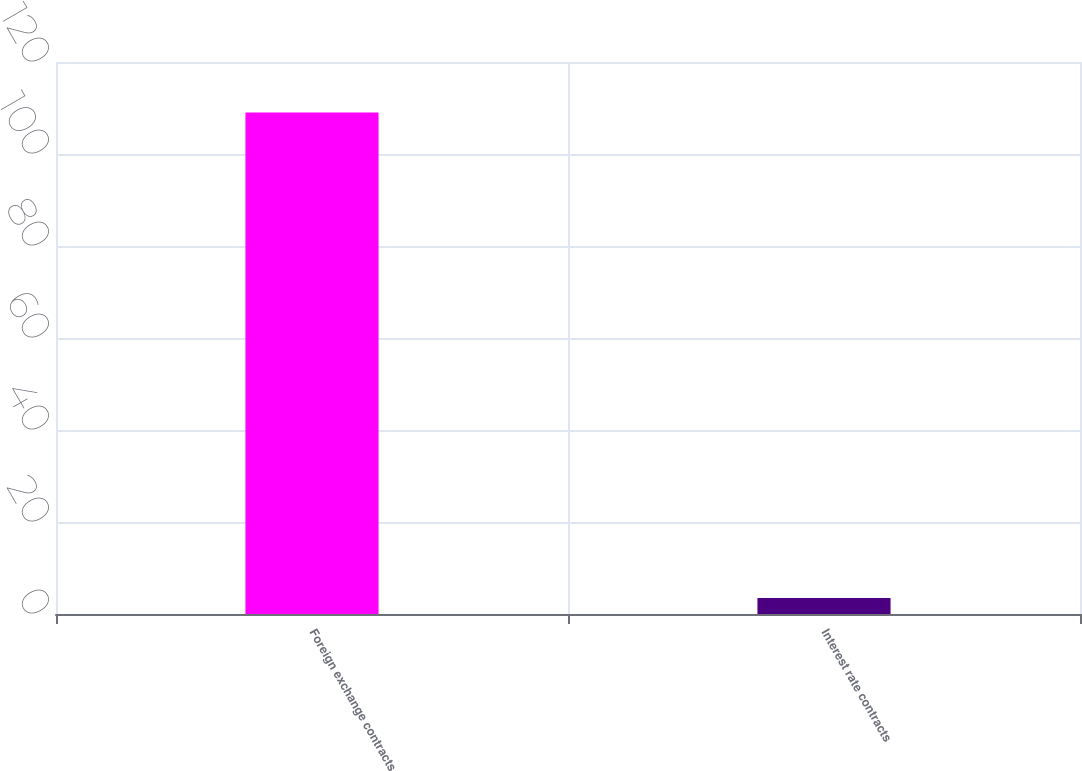<chart> <loc_0><loc_0><loc_500><loc_500><bar_chart><fcel>Foreign exchange contracts<fcel>Interest rate contracts<nl><fcel>109<fcel>3.49<nl></chart> 